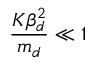<formula> <loc_0><loc_0><loc_500><loc_500>\frac { K \beta _ { d } ^ { 2 } } { m _ { d } } \ll 1</formula> 